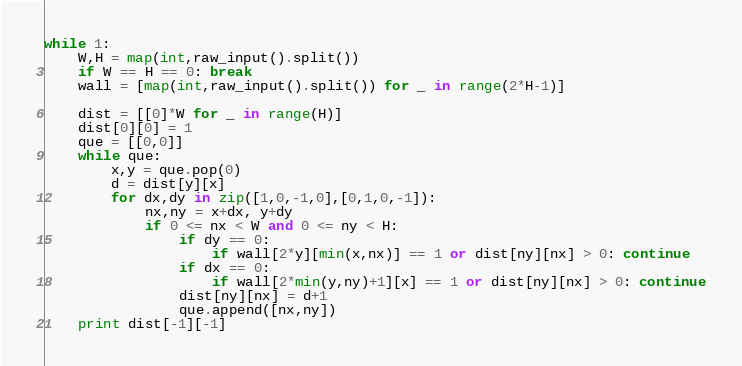Convert code to text. <code><loc_0><loc_0><loc_500><loc_500><_Python_>while 1:
    W,H = map(int,raw_input().split())
    if W == H == 0: break
    wall = [map(int,raw_input().split()) for _ in range(2*H-1)]
    
    dist = [[0]*W for _ in range(H)]
    dist[0][0] = 1
    que = [[0,0]]
    while que:
        x,y = que.pop(0)
        d = dist[y][x]
        for dx,dy in zip([1,0,-1,0],[0,1,0,-1]):
            nx,ny = x+dx, y+dy
            if 0 <= nx < W and 0 <= ny < H:
                if dy == 0:
                    if wall[2*y][min(x,nx)] == 1 or dist[ny][nx] > 0: continue
                if dx == 0:
                    if wall[2*min(y,ny)+1][x] == 1 or dist[ny][nx] > 0: continue
                dist[ny][nx] = d+1
                que.append([nx,ny])
    print dist[-1][-1]                    </code> 